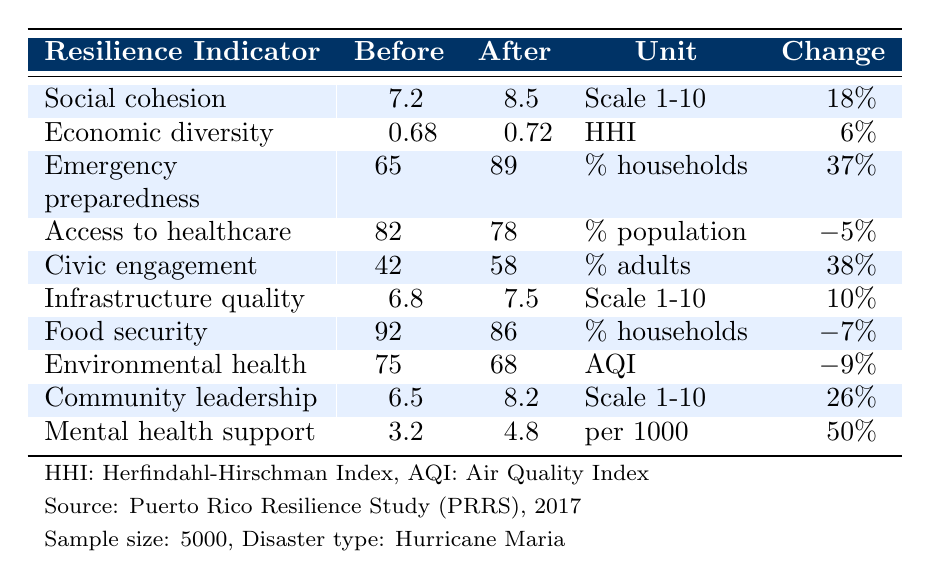What was the value of social cohesion before the disaster? The table shows that the value of social cohesion before the disaster was 7.2.
Answer: 7.2 What percentage of households had emergency kits after the disaster? According to the table, 89% of households had emergency kits after the disaster.
Answer: 89% Did access to healthcare increase after the disaster? By comparing the percentages, access to healthcare decreased from 82% to 78%, indicating a decline.
Answer: No What was the change in community leadership score after the disaster? The score for community leadership increased from 6.5 to 8.2, which is a change of +26%.
Answer: +26% What is the average percentage change for the resilience indicators listed (excluding negative changes)? To find the average percentage change for the positive indicators, we take the changes: +18%, +6%, +37%, +38%, +10%, +26%, +50%. The total is 18 + 6 + 37 + 38 + 10 + 26 + 50 = 185. 
There are 7 indicators, but we only count the positive ones: +18%, +6%, +37%, +38%, +10%, +26%, +50% = 185, with 7 indicators resulting in an average of 185/7 ≈ 26.43%.
Answer: Approximately 26.43% Was the food security percentage higher before or after the disaster? The table indicates that food security was at 92% before the disaster and dropped to 86% after, showing it was higher before the disaster.
Answer: Before the disaster What was the change in mental health support per 1000 people after the disaster? Mental health support increased from 3.2 to 4.8 per 1000 people, which is an increase of +50%.
Answer: +50% Which resilience indicator had the highest percentage of change after the disaster? By reviewing the percentage changes, mental health support had the highest increase at +50%.
Answer: Mental health support How does the decrease in environmental health compare to the increase in emergency preparedness? Environmental health decreased by -9%, while emergency preparedness increased by +37%, indicating a net positive effect overall despite the decrease in environmental health.
Answer: Positive net effect overall 